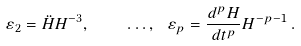Convert formula to latex. <formula><loc_0><loc_0><loc_500><loc_500>\varepsilon _ { 2 } = \ddot { H } H ^ { - 3 } , \quad \dots , \ \varepsilon _ { p } = \frac { d ^ { p } H } { d t ^ { p } } H ^ { - p - 1 } \, .</formula> 